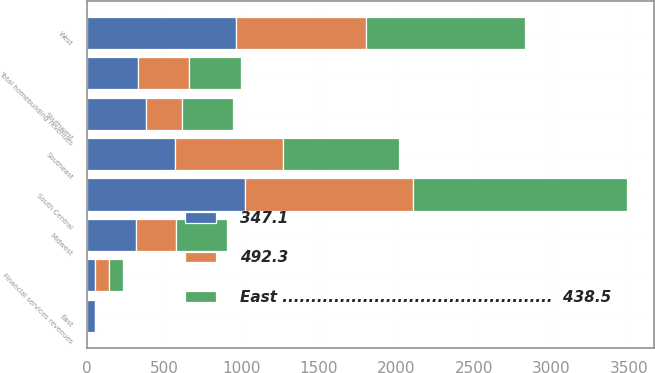Convert chart. <chart><loc_0><loc_0><loc_500><loc_500><stacked_bar_chart><ecel><fcel>Midwest<fcel>Southeast<fcel>South Central<fcel>Southwest<fcel>West<fcel>Total homebuilding revenues<fcel>Financial services revenues<fcel>East<nl><fcel>492.3<fcel>261.5<fcel>696.8<fcel>1081<fcel>234.8<fcel>837<fcel>331<fcel>87.2<fcel>3.5<nl><fcel>East ...............................................  438.5<fcel>331<fcel>747.6<fcel>1383.5<fcel>329.7<fcel>1025.6<fcel>331<fcel>90.5<fcel>9<nl><fcel>347.1<fcel>314.5<fcel>570.8<fcel>1024.6<fcel>382.4<fcel>964.5<fcel>331<fcel>53.7<fcel>54.3<nl></chart> 